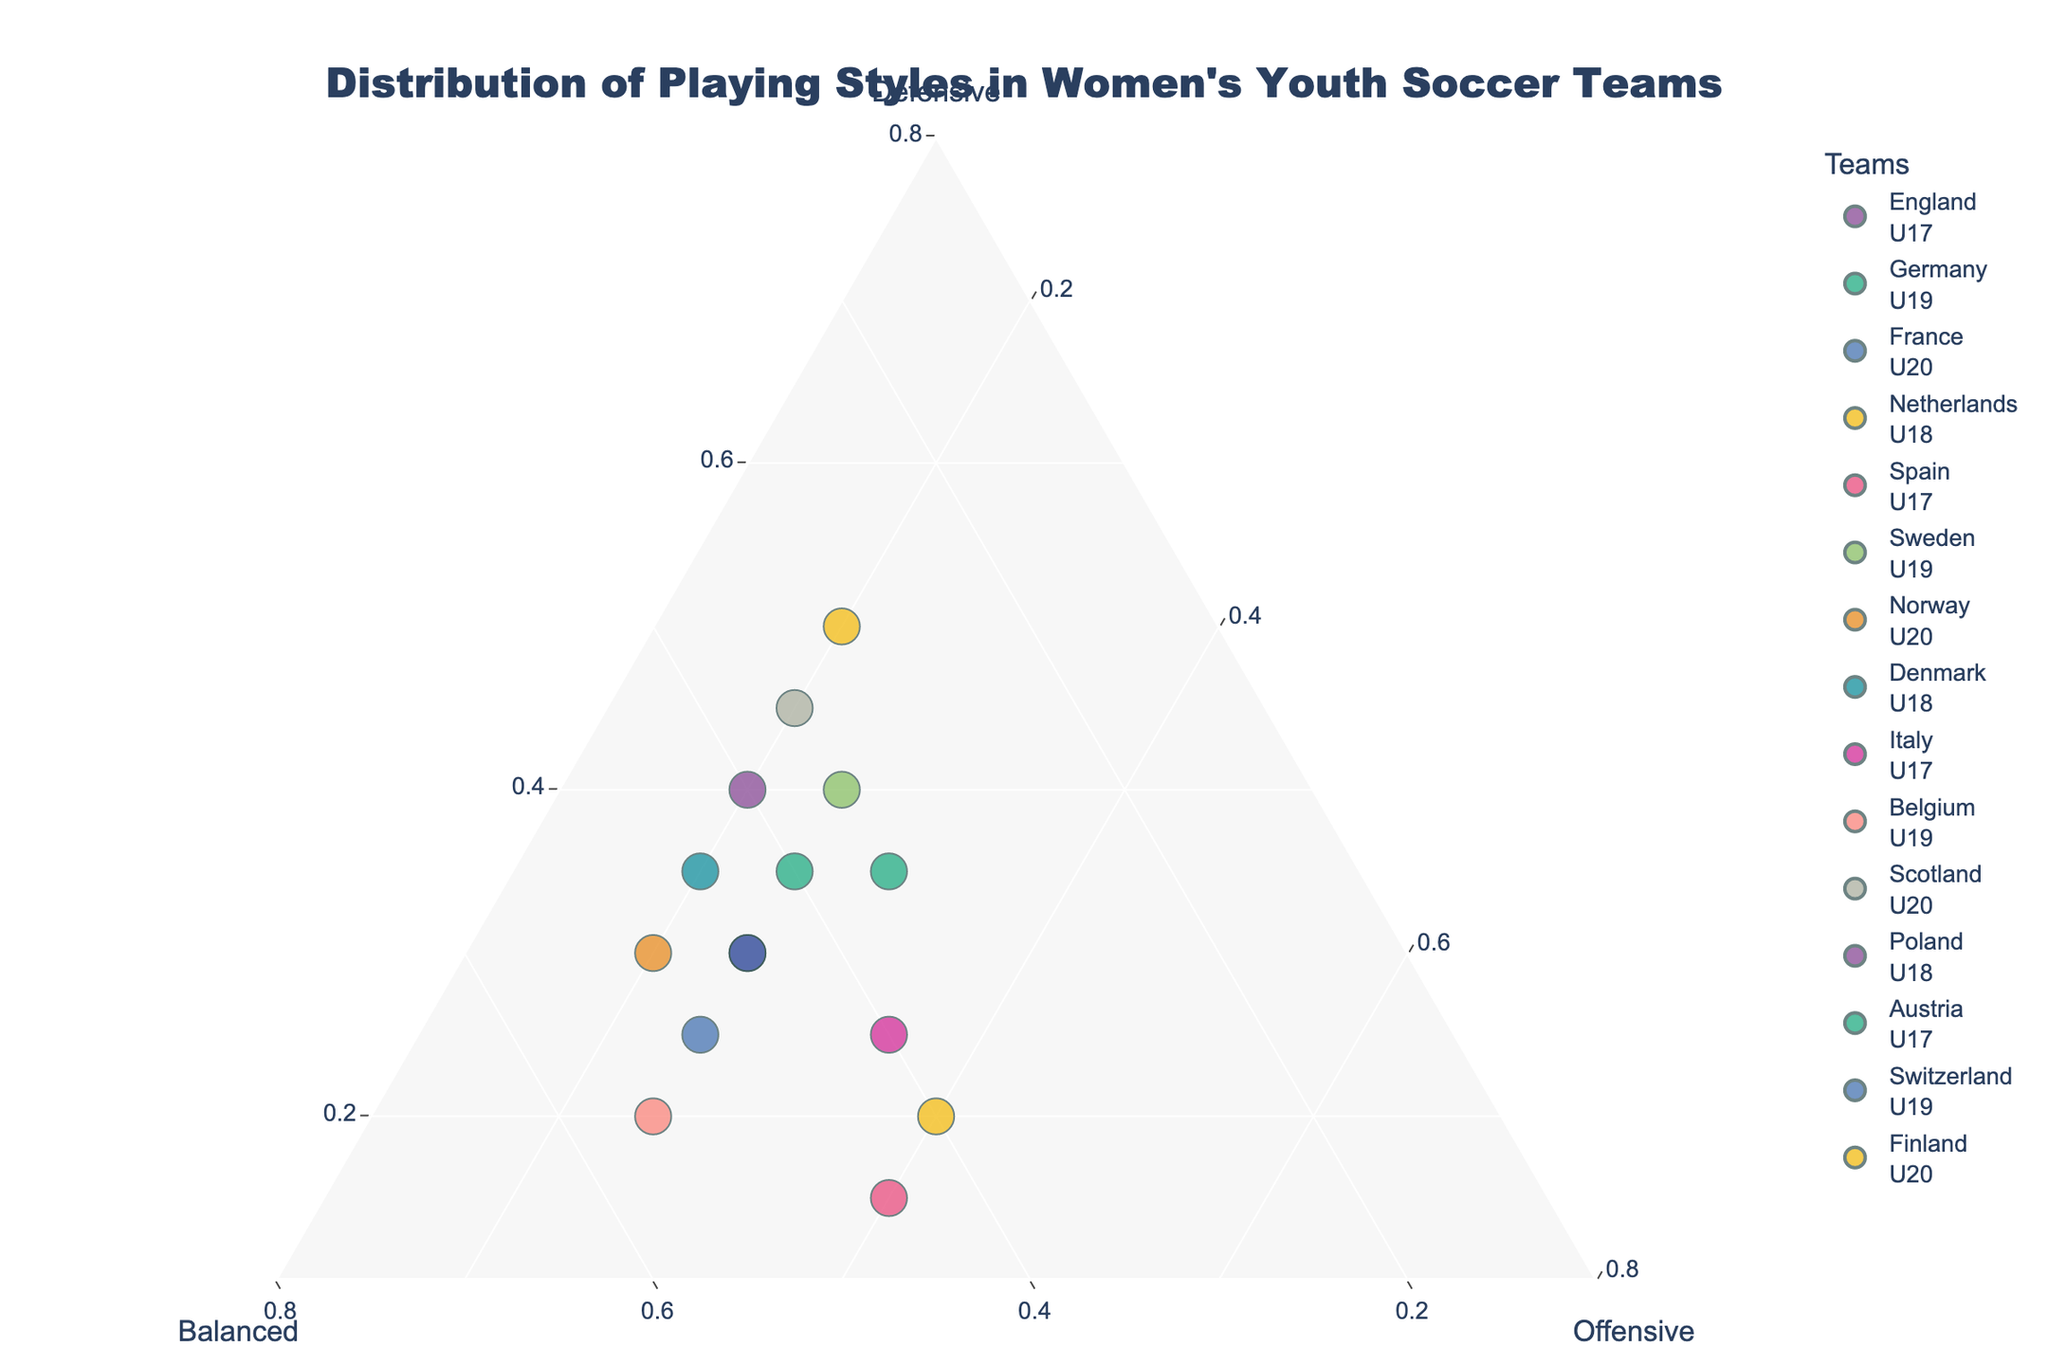What's the title of the plot? The title of the plot can be found at the top center of the figure. It is designed to summarize the content of the plot.
Answer: Distribution of Playing Styles in Women's Youth Soccer Teams Which team has the highest percentage of offensive play? To determine which team has the highest offensive percentage, look for the point that is closest to the "Offensive" vertex.
Answer: Netherlands U18 and Spain U17 (Both 40%) How many teams have a balanced style of at least 50%? Analyze the data points along the "Balanced" axis to find the number of teams with a balanced style of 50% or more.
Answer: 3 teams (France U20, Norway U20, Belgium U19) Which two teams have the same playing style distribution? Compare the data points to see if any teams share identical values for Defensive, Balanced, and Offensive play.
Answer: None Which team is closest to having an equal distribution of all three playing styles? A team with equal distribution would be near the center of the plot, equally distant from all vertices. Look for the point closest to the center.
Answer: None (most balanced team is France U20 with 25, 50, and 25) What is the percentage of defensive play for Finland U20? Locate the Finland U20 data point and check the corresponding percentage value for defensive play.
Answer: 50% Which team has the lowest percentage of balanced play? Identify the data point closest to the "Defensive-Offensive" edge, indicating lower balanced values.
Answer: Finland U20 (30%) Compare the playing styles of England U17 and Germany U19. Which team is more balanced? Check the values for "Balanced" for both teams and compare them directly.
Answer: Germany U19 (40% vs. England U17's 45%) What is the average percentage of defensive play among all teams? Sum the defensive percentages for all teams and divide by the number of teams to get the average. 30+35+25+20+15+40+30+35+25+20+45+40+35+30+50 = 475. Number of teams = 15. Average = 475/15
Answer: 31.67% Which team has a combination of styles with 45% balanced play but differs in their defensive and offensive proportions? Look for teams with exactly 45% in the balanced category and compare their defensive and offensive values.
Answer: Teams are: England U17, Spain U17, Denmark U18, Switzerland U19 